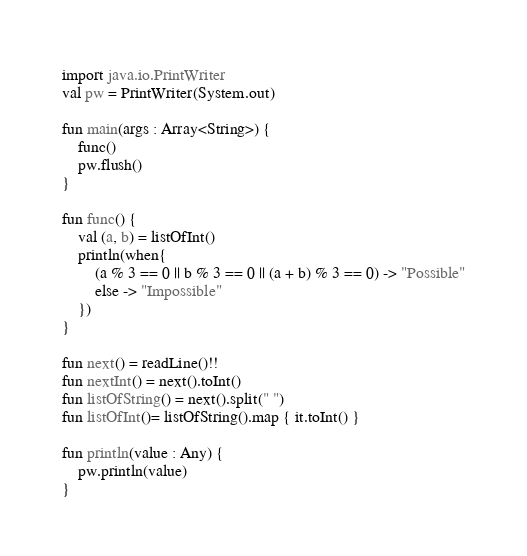Convert code to text. <code><loc_0><loc_0><loc_500><loc_500><_Kotlin_>import java.io.PrintWriter
val pw = PrintWriter(System.out)

fun main(args : Array<String>) {
    func()
    pw.flush()
}

fun func() {
    val (a, b) = listOfInt()
    println(when{
        (a % 3 == 0 || b % 3 == 0 || (a + b) % 3 == 0) -> "Possible"
        else -> "Impossible"
    })
}

fun next() = readLine()!!
fun nextInt() = next().toInt()
fun listOfString() = next().split(" ")
fun listOfInt()= listOfString().map { it.toInt() }

fun println(value : Any) {
    pw.println(value)
}</code> 